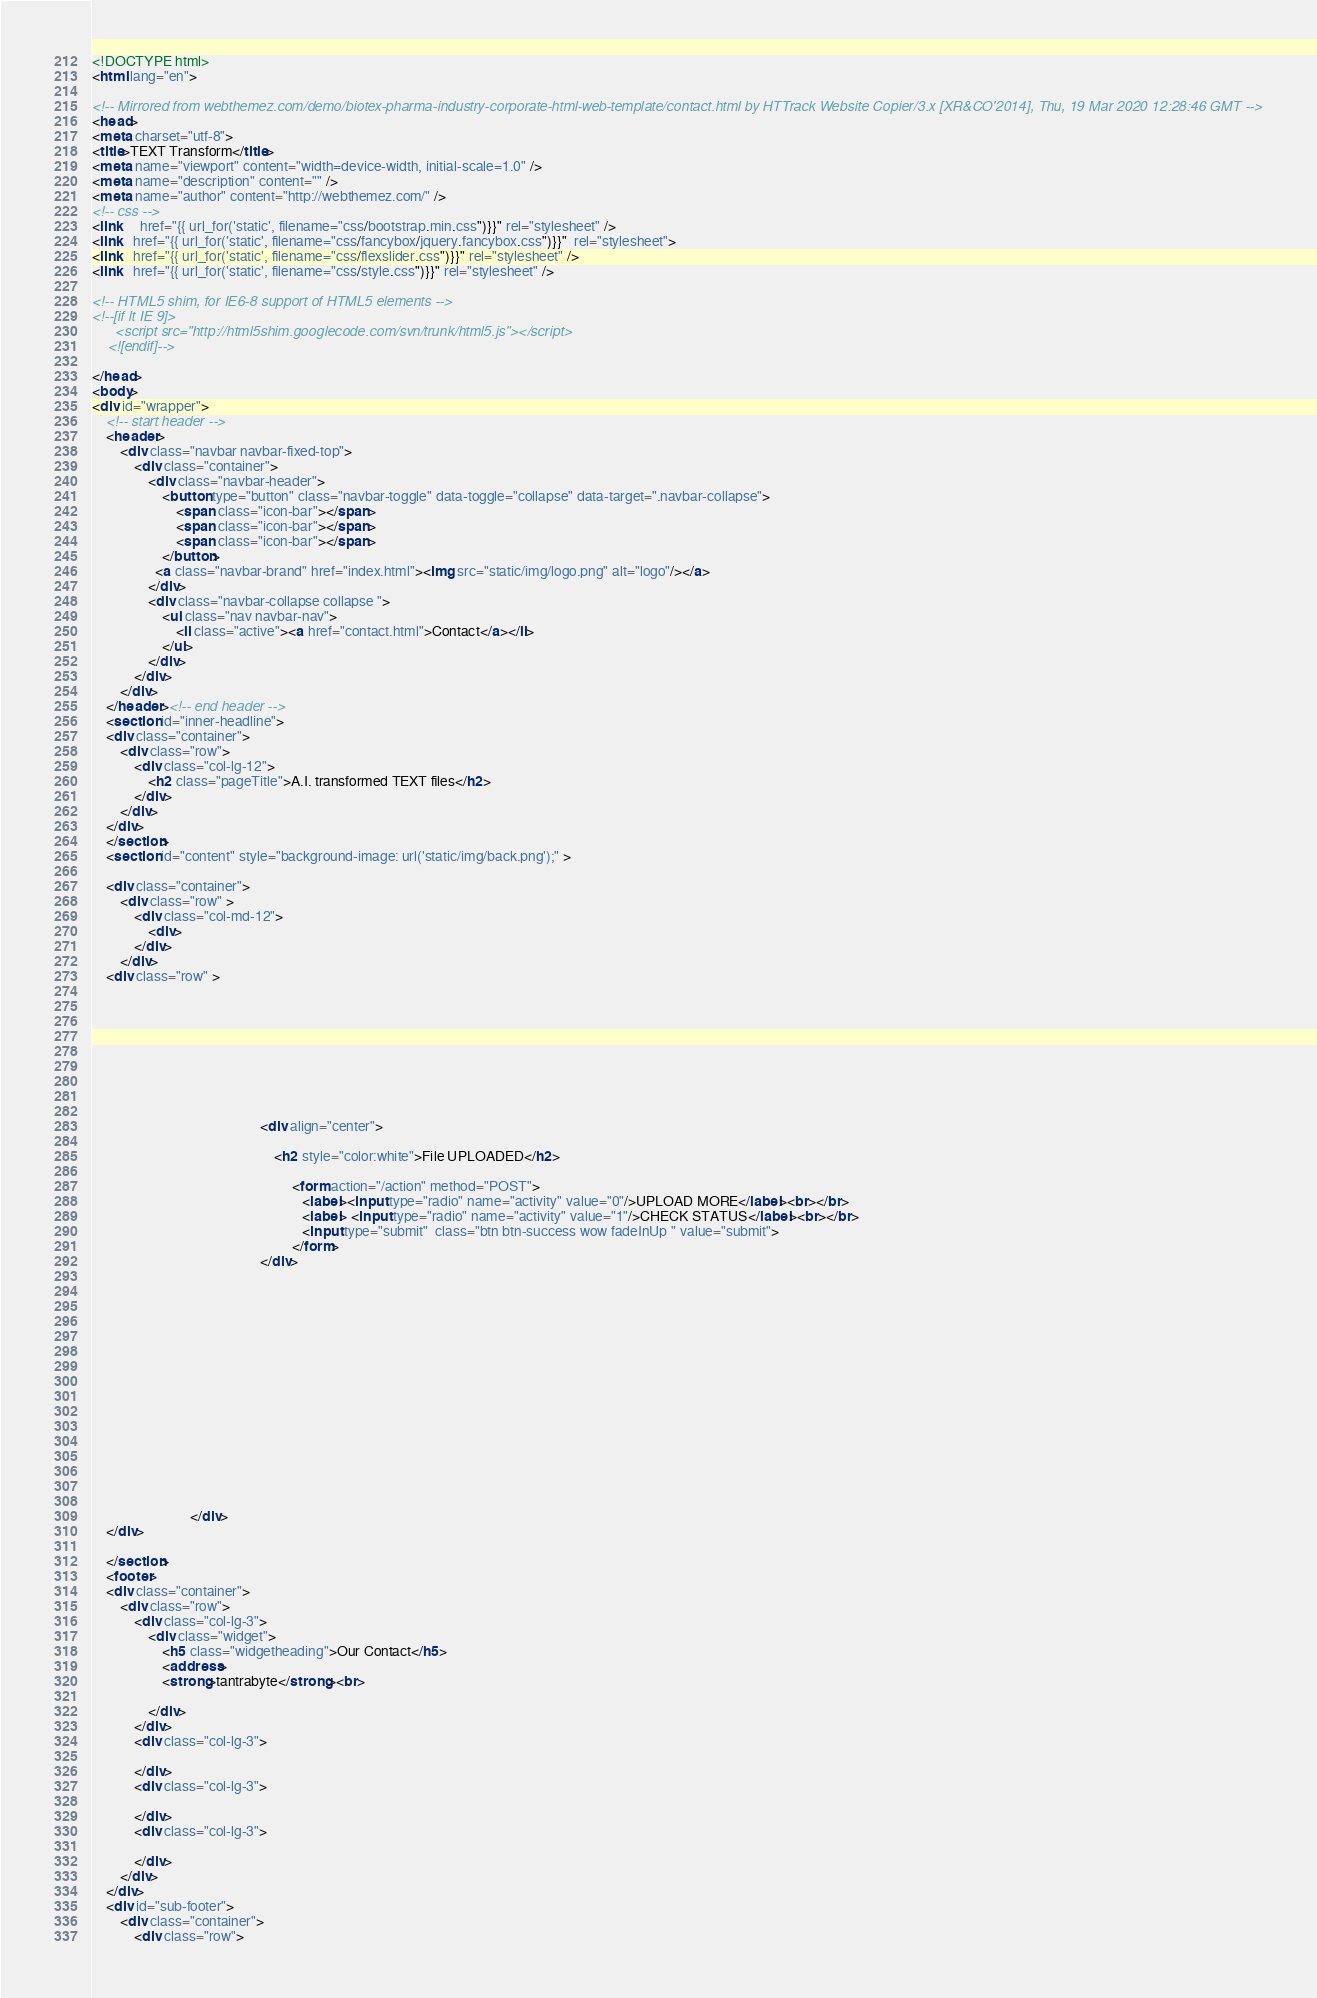<code> <loc_0><loc_0><loc_500><loc_500><_HTML_><!DOCTYPE html>
<html lang="en">

<!-- Mirrored from webthemez.com/demo/biotex-pharma-industry-corporate-html-web-template/contact.html by HTTrack Website Copier/3.x [XR&CO'2014], Thu, 19 Mar 2020 12:28:46 GMT -->
<head>
<meta charset="utf-8">
<title>TEXT Transform</title>
<meta name="viewport" content="width=device-width, initial-scale=1.0" />
<meta name="description" content="" />
<meta name="author" content="http://webthemez.com/" />
<!-- css -->
<link     href="{{ url_for('static', filename="css/bootstrap.min.css")}}" rel="stylesheet" />
<link   href="{{ url_for('static', filename="css/fancybox/jquery.fancybox.css")}}"  rel="stylesheet"> 
<link   href="{{ url_for('static', filename="css/flexslider.css")}}" rel="stylesheet" />
<link   href="{{ url_for('static', filename="css/style.css")}}" rel="stylesheet" />
 
<!-- HTML5 shim, for IE6-8 support of HTML5 elements -->
<!--[if lt IE 9]>
      <script src="http://html5shim.googlecode.com/svn/trunk/html5.js"></script>
    <![endif]-->

</head>
<body>
<div id="wrapper">
	<!-- start header -->
	<header>
        <div class="navbar navbar-fixed-top">
            <div class="container">
                <div class="navbar-header">
                    <button type="button" class="navbar-toggle" data-toggle="collapse" data-target=".navbar-collapse">
                        <span class="icon-bar"></span>
                        <span class="icon-bar"></span>
                        <span class="icon-bar"></span>
                    </button>
                  <a class="navbar-brand" href="index.html"><img src="static/img/logo.png" alt="logo"/></a>
                </div>
                <div class="navbar-collapse collapse ">
                    <ul class="nav navbar-nav">
                        <li class="active"><a href="contact.html">Contact</a></li>
                    </ul>
                </div>
            </div>
        </div>
	</header><!-- end header -->
	<section id="inner-headline">
	<div class="container">
		<div class="row">
			<div class="col-lg-12">
				<h2 class="pageTitle">A.I. transformed TEXT files</h2>
			</div>
		</div>
	</div>
	</section>
	<section id="content" style="background-image: url('static/img/back.png');" >
	
	<div class="container">
		<div class="row" >
			<div class="col-md-12">
				<div>
			</div>
		</div>
	<div class="row" >
	
	
	
	
	
	
	
							
								     
												<div align="center">
													
													<h2 style="color:white">File UPLOADED</h2>

														 <form action="/action" method="POST">
															<label><input type="radio" name="activity" value="0"/>UPLOAD MORE</label><br></br>
															<label> <input type="radio" name="activity" value="1"/>CHECK STATUS</label><br></br>
															<input type="submit"  class="btn btn-success wow fadeInUp " value="submit">
														 </form>
												</div>
							
								
								
								
								
								
								
								
								
								
								
	
	
	
							
								
							</div>
	</div>
 
	</section>
	<footer>
	<div class="container">
		<div class="row">
			<div class="col-lg-3">
				<div class="widget">
					<h5 class="widgetheading">Our Contact</h5>
					<address>
					<strong>tantrabyte</strong><br>
					
				</div>
			</div>
			<div class="col-lg-3">
				
			</div>
			<div class="col-lg-3">
				
			</div>
			<div class="col-lg-3">
					
			</div>
		</div>
	</div>
	<div id="sub-footer">
		<div class="container">
			<div class="row"></code> 